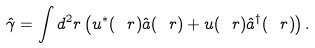Convert formula to latex. <formula><loc_0><loc_0><loc_500><loc_500>\hat { \gamma } = \int d ^ { 2 } r \left ( u ^ { * } ( \ r ) \hat { a } ( \ r ) + u ( \ r ) \hat { a } ^ { \dagger } ( \ r ) \right ) .</formula> 